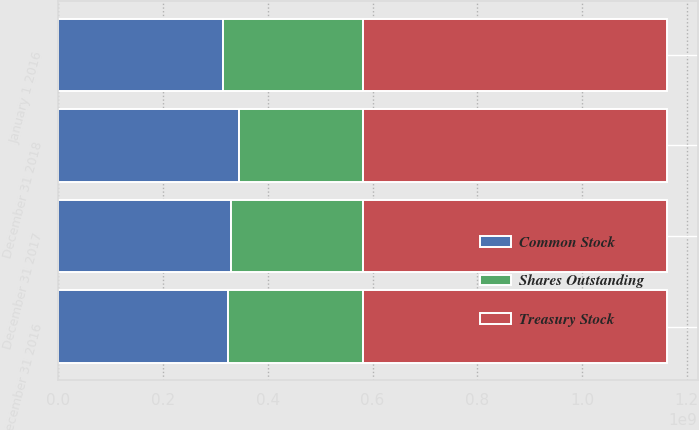Convert chart to OTSL. <chart><loc_0><loc_0><loc_500><loc_500><stacked_bar_chart><ecel><fcel>January 1 2016<fcel>December 31 2016<fcel>December 31 2017<fcel>December 31 2018<nl><fcel>Treasury Stock<fcel>5.81146e+08<fcel>5.81146e+08<fcel>5.81146e+08<fcel>5.81146e+08<nl><fcel>Common Stock<fcel>3.1427e+08<fcel>3.23816e+08<fcel>3.29972e+08<fcel>3.45285e+08<nl><fcel>Shares Outstanding<fcel>2.66876e+08<fcel>2.5733e+08<fcel>2.51174e+08<fcel>2.35861e+08<nl></chart> 